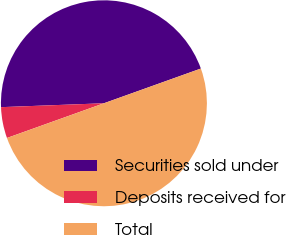Convert chart to OTSL. <chart><loc_0><loc_0><loc_500><loc_500><pie_chart><fcel>Securities sold under<fcel>Deposits received for<fcel>Total<nl><fcel>45.13%<fcel>4.87%<fcel>50.0%<nl></chart> 